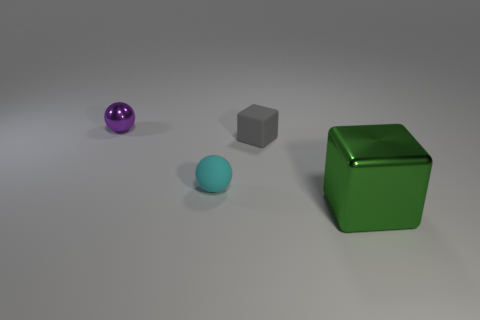There is a metal object that is to the right of the purple sphere; is it the same shape as the tiny object in front of the gray thing?
Give a very brief answer. No. How many rubber things are to the right of the rubber ball and in front of the matte cube?
Give a very brief answer. 0. Are there any other metallic things of the same color as the big object?
Your answer should be very brief. No. There is a gray rubber object that is the same size as the cyan sphere; what is its shape?
Provide a succinct answer. Cube. There is a tiny rubber block; are there any gray cubes behind it?
Provide a short and direct response. No. Is the ball that is to the right of the tiny purple shiny ball made of the same material as the cube behind the big shiny object?
Your answer should be compact. Yes. What number of purple metal spheres have the same size as the green object?
Keep it short and to the point. 0. What is the material of the block that is in front of the small rubber cube?
Offer a very short reply. Metal. What number of tiny cyan rubber objects are the same shape as the tiny gray rubber object?
Ensure brevity in your answer.  0. There is another object that is made of the same material as the cyan object; what shape is it?
Provide a succinct answer. Cube. 